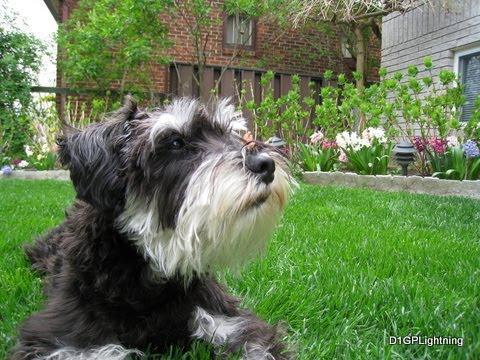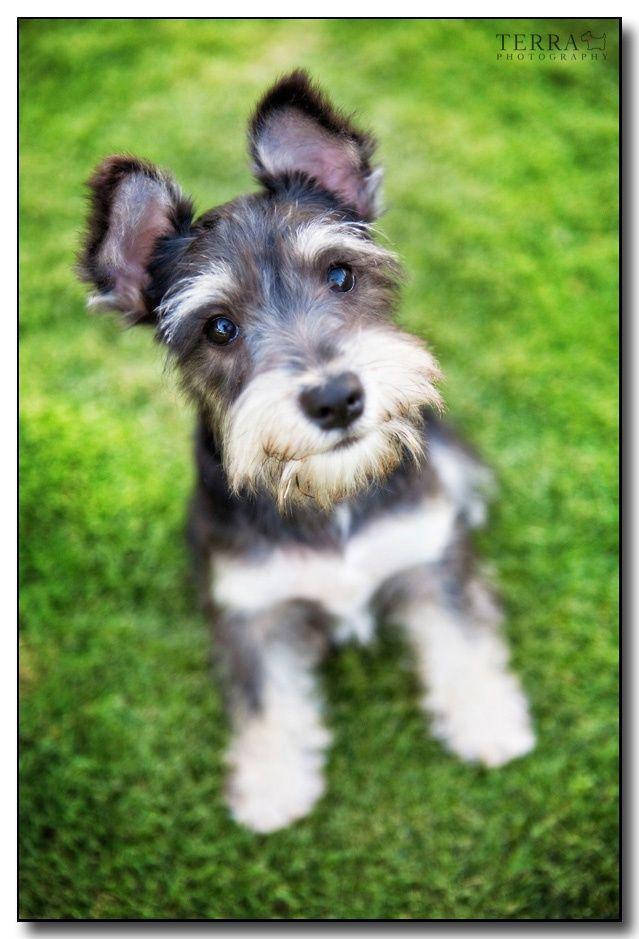The first image is the image on the left, the second image is the image on the right. Analyze the images presented: Is the assertion "In one of the images there is a single dog that is holding something in its mouth and in the other there are two dogs playing." valid? Answer yes or no. No. 